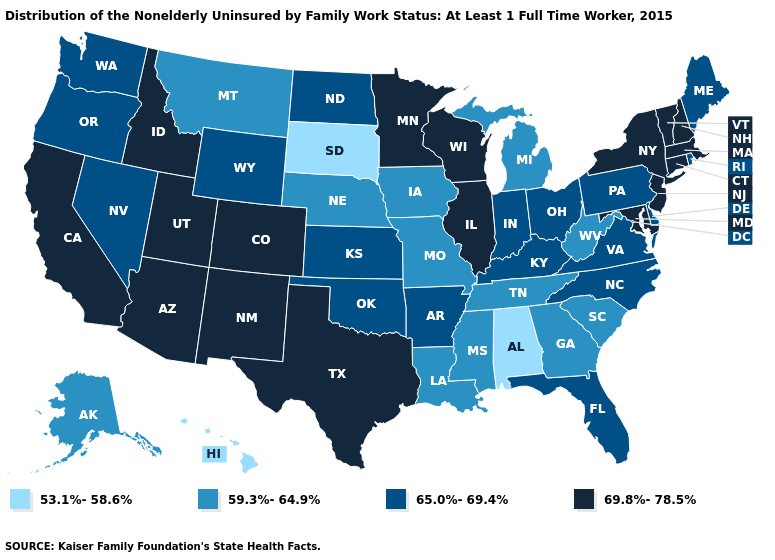What is the value of Nevada?
Answer briefly. 65.0%-69.4%. Name the states that have a value in the range 59.3%-64.9%?
Give a very brief answer. Alaska, Georgia, Iowa, Louisiana, Michigan, Mississippi, Missouri, Montana, Nebraska, South Carolina, Tennessee, West Virginia. Does Vermont have the highest value in the USA?
Quick response, please. Yes. What is the value of Vermont?
Keep it brief. 69.8%-78.5%. Among the states that border Minnesota , which have the highest value?
Write a very short answer. Wisconsin. Name the states that have a value in the range 59.3%-64.9%?
Write a very short answer. Alaska, Georgia, Iowa, Louisiana, Michigan, Mississippi, Missouri, Montana, Nebraska, South Carolina, Tennessee, West Virginia. How many symbols are there in the legend?
Be succinct. 4. What is the value of Massachusetts?
Give a very brief answer. 69.8%-78.5%. Name the states that have a value in the range 59.3%-64.9%?
Answer briefly. Alaska, Georgia, Iowa, Louisiana, Michigan, Mississippi, Missouri, Montana, Nebraska, South Carolina, Tennessee, West Virginia. What is the value of Minnesota?
Write a very short answer. 69.8%-78.5%. Name the states that have a value in the range 59.3%-64.9%?
Short answer required. Alaska, Georgia, Iowa, Louisiana, Michigan, Mississippi, Missouri, Montana, Nebraska, South Carolina, Tennessee, West Virginia. Among the states that border Kentucky , which have the highest value?
Answer briefly. Illinois. What is the value of South Carolina?
Concise answer only. 59.3%-64.9%. Name the states that have a value in the range 59.3%-64.9%?
Be succinct. Alaska, Georgia, Iowa, Louisiana, Michigan, Mississippi, Missouri, Montana, Nebraska, South Carolina, Tennessee, West Virginia. What is the highest value in states that border New Mexico?
Keep it brief. 69.8%-78.5%. 